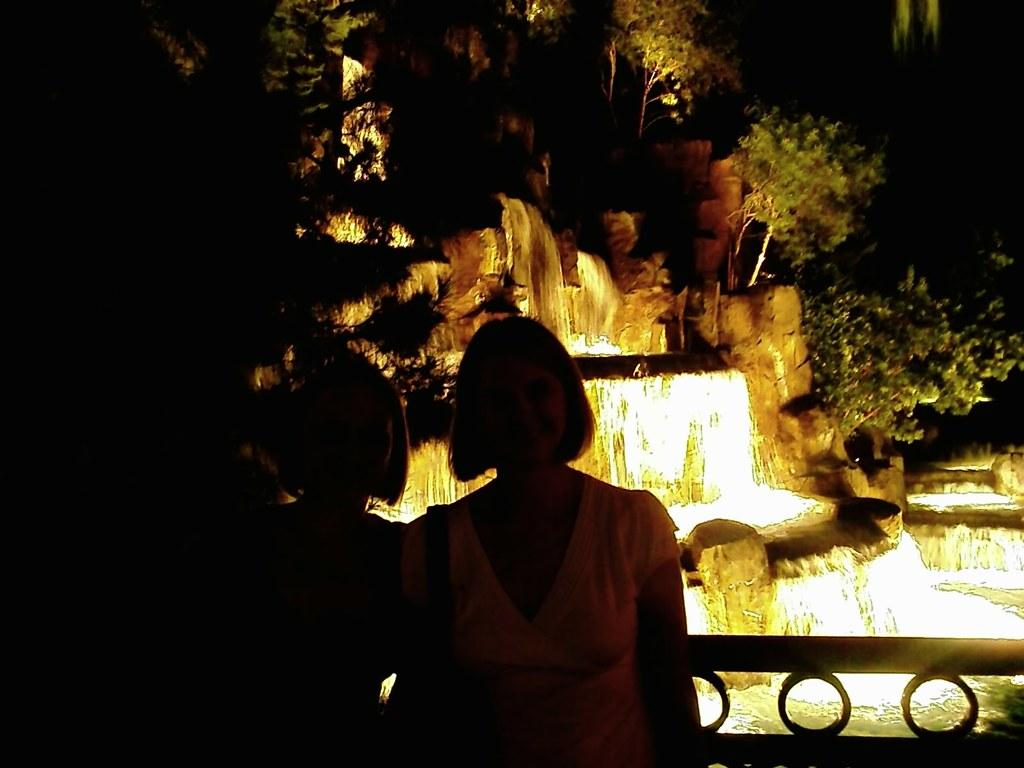How many people are in the image? There are two persons in the image. What are the persons doing in the image? The persons are standing in front of a waterfall. What can be seen in the background of the image? There is a group of trees in the background of the image. What type of punishment is being administered to the pickle in the image? There is no pickle present in the image, and therefore no punishment can be observed. 